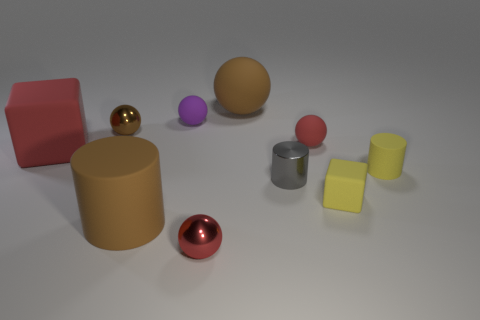The big matte thing that is the same color as the large matte cylinder is what shape?
Give a very brief answer. Sphere. How many cylinders are either small gray metal objects or tiny things?
Make the answer very short. 2. Is the number of rubber spheres in front of the red matte cube the same as the number of tiny red things that are on the right side of the tiny purple rubber thing?
Your answer should be very brief. No. There is a red metal object that is the same shape as the brown metallic thing; what is its size?
Make the answer very short. Small. What is the size of the matte thing that is left of the red metal ball and behind the red matte ball?
Your answer should be compact. Small. There is a big red block; are there any big things right of it?
Your answer should be very brief. Yes. What number of objects are either matte things behind the tiny red rubber sphere or tiny red spheres?
Ensure brevity in your answer.  4. There is a gray object that is behind the red metal object; how many tiny shiny things are left of it?
Your response must be concise. 2. Is the number of metal spheres that are in front of the small block less than the number of rubber things behind the tiny purple rubber sphere?
Your answer should be very brief. No. The large rubber thing that is behind the tiny red thing on the right side of the gray shiny cylinder is what shape?
Ensure brevity in your answer.  Sphere. 